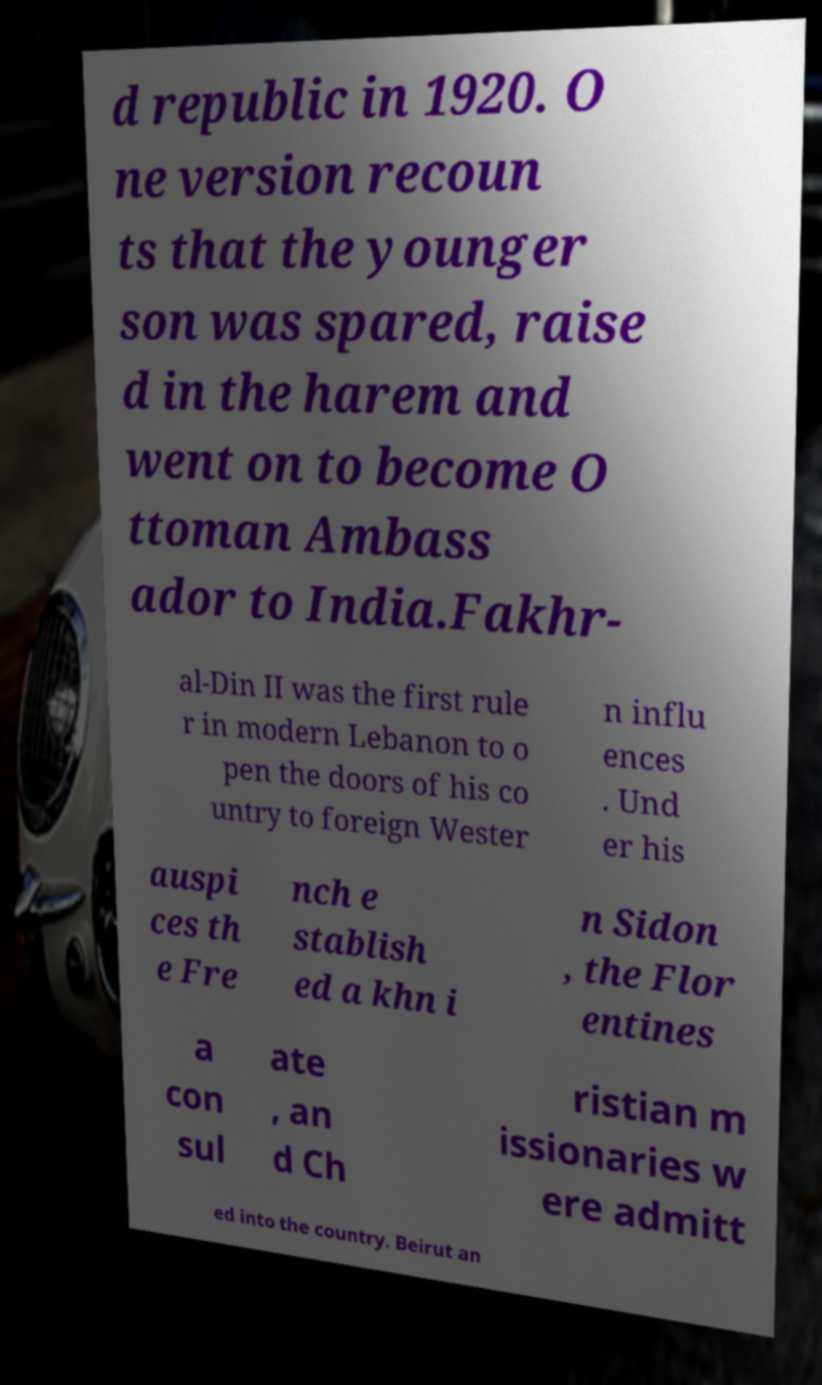Can you accurately transcribe the text from the provided image for me? d republic in 1920. O ne version recoun ts that the younger son was spared, raise d in the harem and went on to become O ttoman Ambass ador to India.Fakhr- al-Din II was the first rule r in modern Lebanon to o pen the doors of his co untry to foreign Wester n influ ences . Und er his auspi ces th e Fre nch e stablish ed a khn i n Sidon , the Flor entines a con sul ate , an d Ch ristian m issionaries w ere admitt ed into the country. Beirut an 